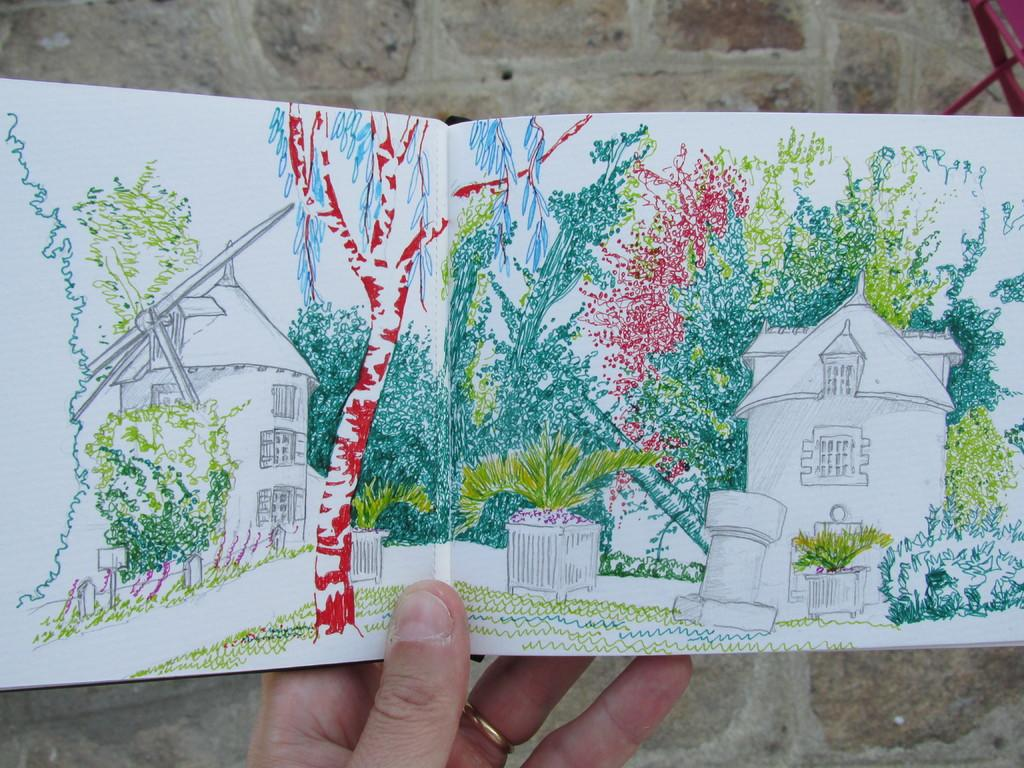What is being held by the hand in the image? There is a hand holding a book in the image. What type of content does the book contain? The book contains art. What can be seen in the background of the image? There is a wall in the background of the image. What is the comfort level of the chair in the image? There is no chair present in the image, so it is not possible to determine the comfort level. 